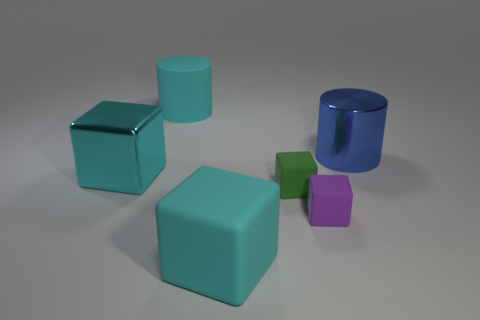Subtract all purple rubber blocks. How many blocks are left? 3 Add 1 purple matte cubes. How many objects exist? 7 Subtract all cyan blocks. How many blocks are left? 2 Subtract all brown spheres. How many purple cubes are left? 1 Subtract all blocks. How many objects are left? 2 Subtract all red blocks. Subtract all purple balls. How many blocks are left? 4 Add 2 rubber cylinders. How many rubber cylinders are left? 3 Add 6 large purple matte cylinders. How many large purple matte cylinders exist? 6 Subtract 1 cyan cylinders. How many objects are left? 5 Subtract 3 blocks. How many blocks are left? 1 